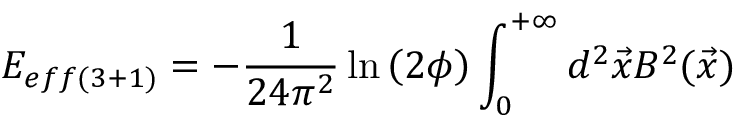Convert formula to latex. <formula><loc_0><loc_0><loc_500><loc_500>E _ { e f f ( 3 + 1 ) } = - \frac { 1 } { 2 4 \pi ^ { 2 } } \ln \left ( 2 \phi \right ) \int _ { 0 } ^ { + \infty } d ^ { 2 } \vec { x } B ^ { 2 } ( \vec { x } )</formula> 